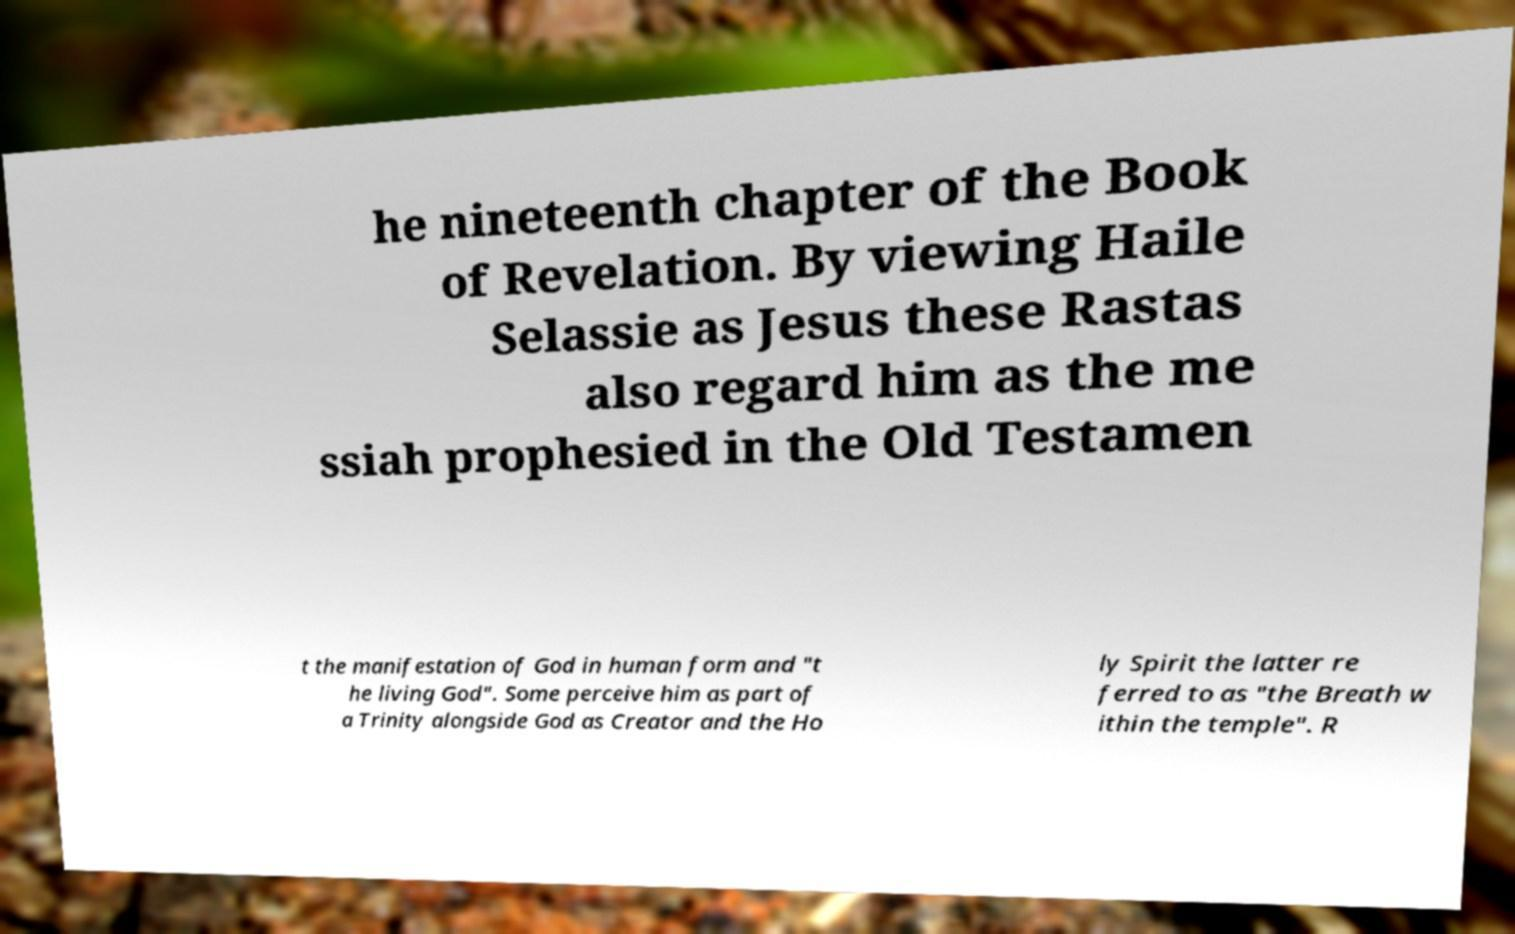Please read and relay the text visible in this image. What does it say? he nineteenth chapter of the Book of Revelation. By viewing Haile Selassie as Jesus these Rastas also regard him as the me ssiah prophesied in the Old Testamen t the manifestation of God in human form and "t he living God". Some perceive him as part of a Trinity alongside God as Creator and the Ho ly Spirit the latter re ferred to as "the Breath w ithin the temple". R 